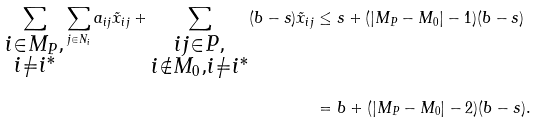Convert formula to latex. <formula><loc_0><loc_0><loc_500><loc_500>\sum _ { \substack { i \in M _ { P } , \\ i \neq i ^ { * } } } \sum _ { j \in N _ { i } } a _ { i j } \tilde { x } _ { i j } + \sum _ { \substack { i j \in P , \\ i \notin M _ { 0 } , i \neq i ^ { * } } } ( b - s ) \tilde { x } _ { i j } & \leq s + ( | M _ { P } - M _ { 0 } | - 1 ) ( b - s ) \\ & = b + ( | M _ { P } - M _ { 0 } | - 2 ) ( b - s ) .</formula> 